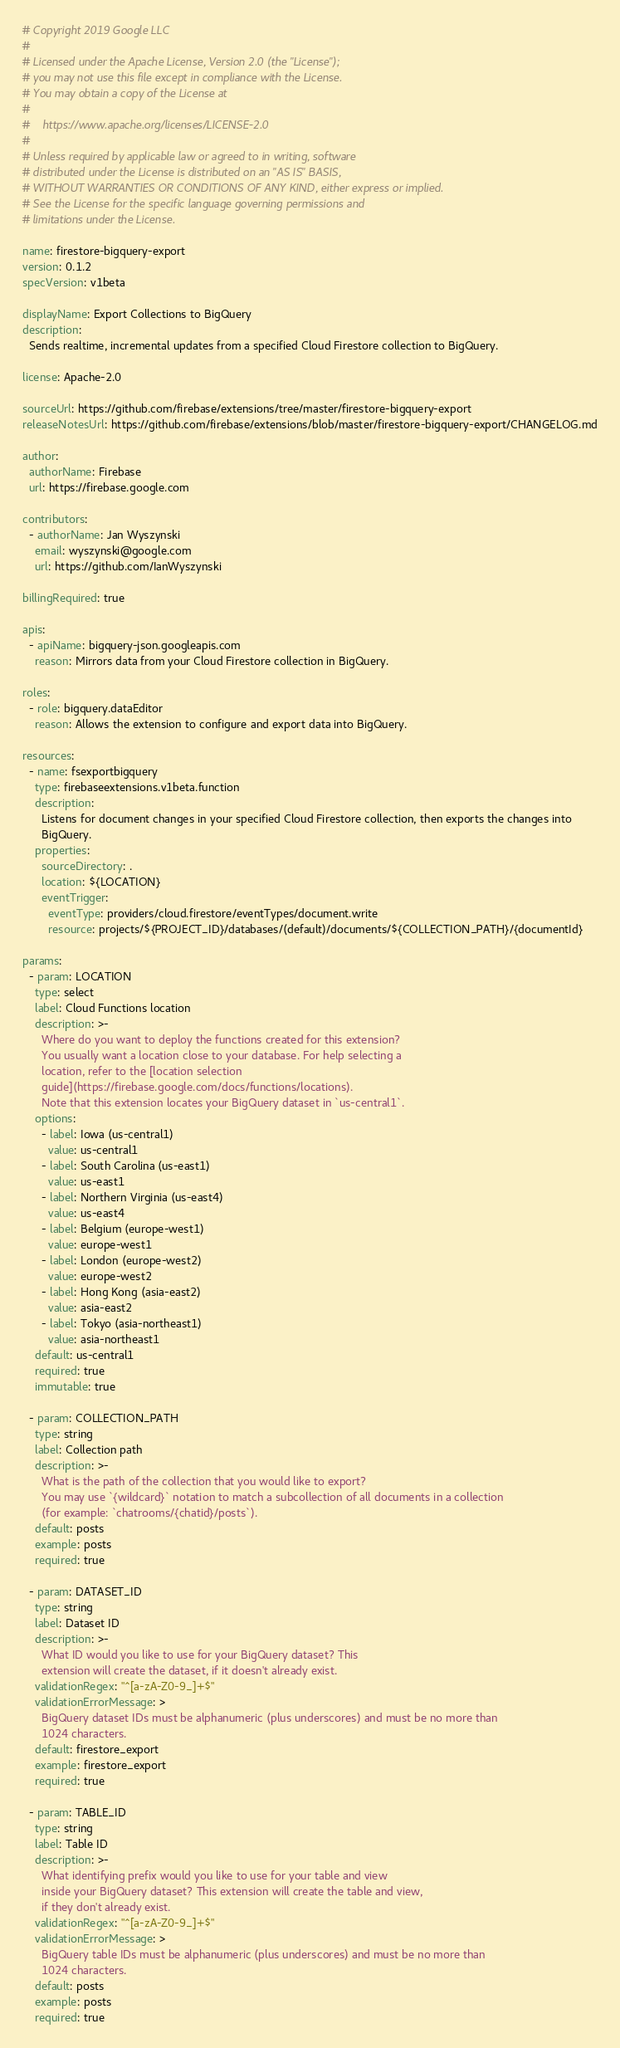Convert code to text. <code><loc_0><loc_0><loc_500><loc_500><_YAML_># Copyright 2019 Google LLC
#
# Licensed under the Apache License, Version 2.0 (the "License");
# you may not use this file except in compliance with the License.
# You may obtain a copy of the License at
#
#    https://www.apache.org/licenses/LICENSE-2.0
#
# Unless required by applicable law or agreed to in writing, software
# distributed under the License is distributed on an "AS IS" BASIS,
# WITHOUT WARRANTIES OR CONDITIONS OF ANY KIND, either express or implied.
# See the License for the specific language governing permissions and
# limitations under the License.

name: firestore-bigquery-export
version: 0.1.2
specVersion: v1beta

displayName: Export Collections to BigQuery
description:
  Sends realtime, incremental updates from a specified Cloud Firestore collection to BigQuery.

license: Apache-2.0

sourceUrl: https://github.com/firebase/extensions/tree/master/firestore-bigquery-export
releaseNotesUrl: https://github.com/firebase/extensions/blob/master/firestore-bigquery-export/CHANGELOG.md

author:
  authorName: Firebase
  url: https://firebase.google.com

contributors:
  - authorName: Jan Wyszynski
    email: wyszynski@google.com
    url: https://github.com/IanWyszynski

billingRequired: true

apis:
  - apiName: bigquery-json.googleapis.com
    reason: Mirrors data from your Cloud Firestore collection in BigQuery.

roles:
  - role: bigquery.dataEditor
    reason: Allows the extension to configure and export data into BigQuery.

resources:
  - name: fsexportbigquery
    type: firebaseextensions.v1beta.function
    description:
      Listens for document changes in your specified Cloud Firestore collection, then exports the changes into
      BigQuery.
    properties:
      sourceDirectory: .
      location: ${LOCATION}
      eventTrigger:
        eventType: providers/cloud.firestore/eventTypes/document.write
        resource: projects/${PROJECT_ID}/databases/(default)/documents/${COLLECTION_PATH}/{documentId}

params:
  - param: LOCATION
    type: select
    label: Cloud Functions location
    description: >-
      Where do you want to deploy the functions created for this extension? 
      You usually want a location close to your database. For help selecting a 
      location, refer to the [location selection 
      guide](https://firebase.google.com/docs/functions/locations). 
      Note that this extension locates your BigQuery dataset in `us-central1`.
    options:
      - label: Iowa (us-central1)
        value: us-central1
      - label: South Carolina (us-east1)
        value: us-east1
      - label: Northern Virginia (us-east4)
        value: us-east4
      - label: Belgium (europe-west1)
        value: europe-west1
      - label: London (europe-west2)
        value: europe-west2
      - label: Hong Kong (asia-east2)
        value: asia-east2
      - label: Tokyo (asia-northeast1)
        value: asia-northeast1
    default: us-central1
    required: true
    immutable: true

  - param: COLLECTION_PATH
    type: string
    label: Collection path
    description: >-
      What is the path of the collection that you would like to export?
      You may use `{wildcard}` notation to match a subcollection of all documents in a collection
      (for example: `chatrooms/{chatid}/posts`).
    default: posts
    example: posts
    required: true

  - param: DATASET_ID
    type: string
    label: Dataset ID
    description: >-
      What ID would you like to use for your BigQuery dataset? This
      extension will create the dataset, if it doesn't already exist.
    validationRegex: "^[a-zA-Z0-9_]+$"
    validationErrorMessage: >
      BigQuery dataset IDs must be alphanumeric (plus underscores) and must be no more than
      1024 characters.
    default: firestore_export
    example: firestore_export
    required: true

  - param: TABLE_ID
    type: string
    label: Table ID
    description: >-
      What identifying prefix would you like to use for your table and view
      inside your BigQuery dataset? This extension will create the table and view,
      if they don't already exist.
    validationRegex: "^[a-zA-Z0-9_]+$"
    validationErrorMessage: >
      BigQuery table IDs must be alphanumeric (plus underscores) and must be no more than
      1024 characters.
    default: posts
    example: posts
    required: true
</code> 